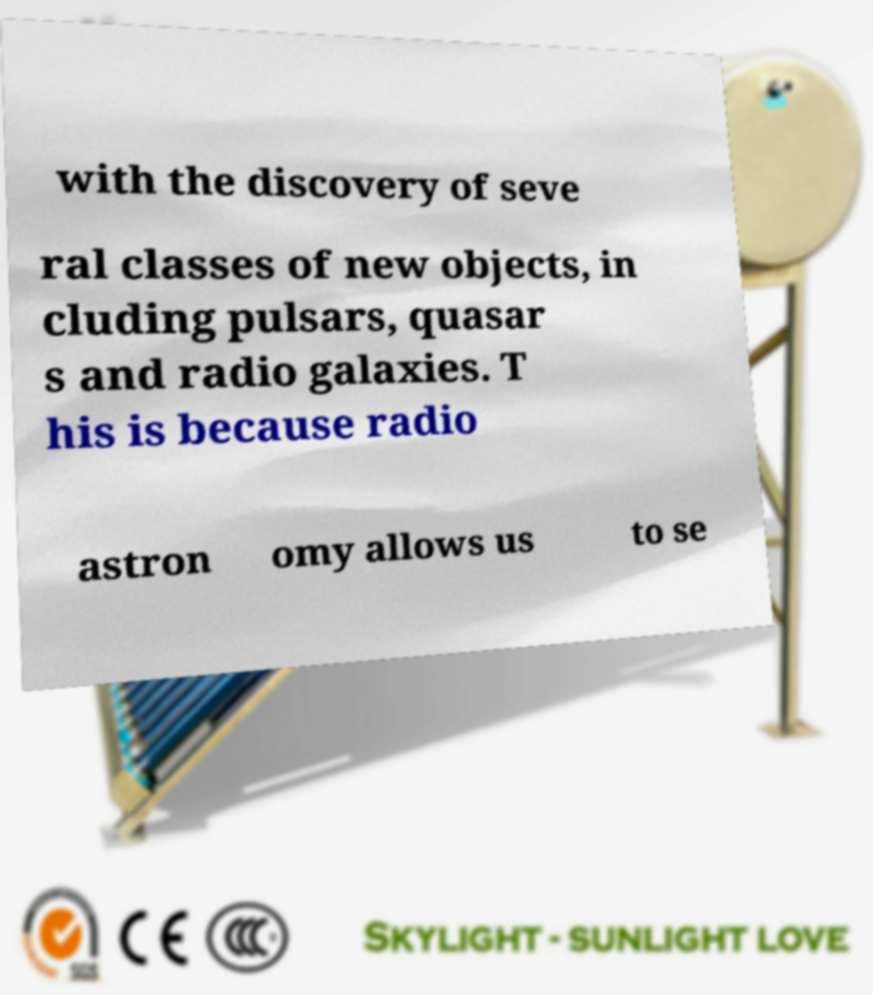Please read and relay the text visible in this image. What does it say? with the discovery of seve ral classes of new objects, in cluding pulsars, quasar s and radio galaxies. T his is because radio astron omy allows us to se 